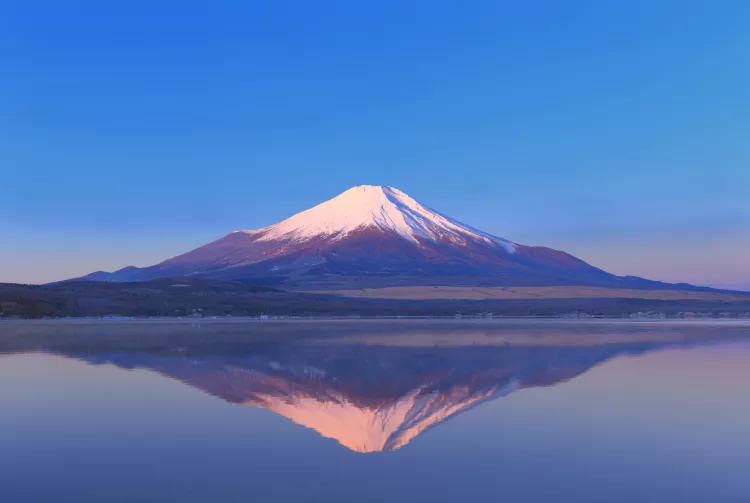What feelings does this image evoke about the place it depicts? This image evokes feelings of awe and serenity, portraying Mount Fuji as a peaceful yet powerful natural monument. The gentle hues of the dawn and the perfect reflection on the lake instill a sense of tranquility and reverence, reflecting the cultural and spiritual significance of Mount Fuji in Japan. Overall, it conveys a sense of harmony between nature and the viewer, eliciting admiration and contemplative quietude. 